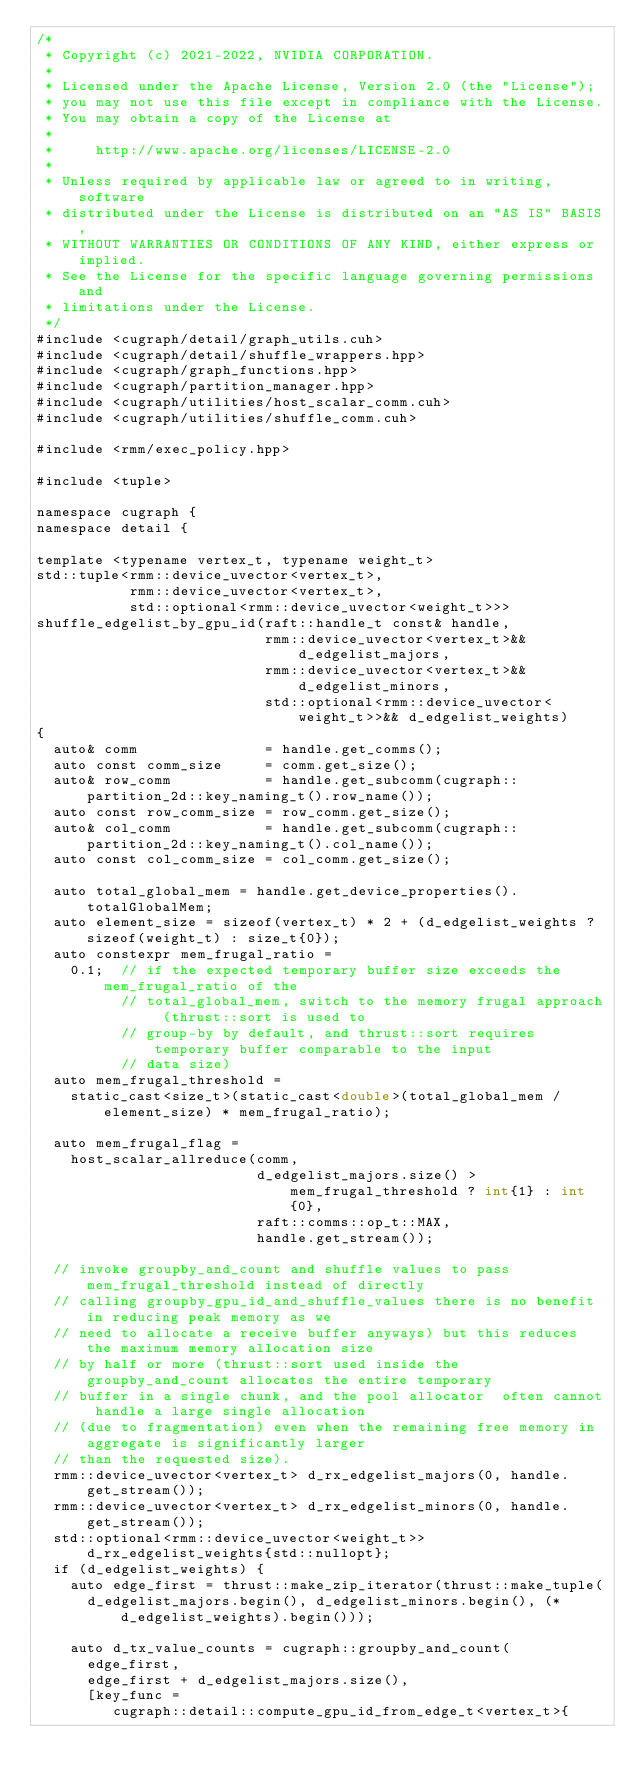<code> <loc_0><loc_0><loc_500><loc_500><_Cuda_>/*
 * Copyright (c) 2021-2022, NVIDIA CORPORATION.
 *
 * Licensed under the Apache License, Version 2.0 (the "License");
 * you may not use this file except in compliance with the License.
 * You may obtain a copy of the License at
 *
 *     http://www.apache.org/licenses/LICENSE-2.0
 *
 * Unless required by applicable law or agreed to in writing, software
 * distributed under the License is distributed on an "AS IS" BASIS,
 * WITHOUT WARRANTIES OR CONDITIONS OF ANY KIND, either express or implied.
 * See the License for the specific language governing permissions and
 * limitations under the License.
 */
#include <cugraph/detail/graph_utils.cuh>
#include <cugraph/detail/shuffle_wrappers.hpp>
#include <cugraph/graph_functions.hpp>
#include <cugraph/partition_manager.hpp>
#include <cugraph/utilities/host_scalar_comm.cuh>
#include <cugraph/utilities/shuffle_comm.cuh>

#include <rmm/exec_policy.hpp>

#include <tuple>

namespace cugraph {
namespace detail {

template <typename vertex_t, typename weight_t>
std::tuple<rmm::device_uvector<vertex_t>,
           rmm::device_uvector<vertex_t>,
           std::optional<rmm::device_uvector<weight_t>>>
shuffle_edgelist_by_gpu_id(raft::handle_t const& handle,
                           rmm::device_uvector<vertex_t>&& d_edgelist_majors,
                           rmm::device_uvector<vertex_t>&& d_edgelist_minors,
                           std::optional<rmm::device_uvector<weight_t>>&& d_edgelist_weights)
{
  auto& comm               = handle.get_comms();
  auto const comm_size     = comm.get_size();
  auto& row_comm           = handle.get_subcomm(cugraph::partition_2d::key_naming_t().row_name());
  auto const row_comm_size = row_comm.get_size();
  auto& col_comm           = handle.get_subcomm(cugraph::partition_2d::key_naming_t().col_name());
  auto const col_comm_size = col_comm.get_size();

  auto total_global_mem = handle.get_device_properties().totalGlobalMem;
  auto element_size = sizeof(vertex_t) * 2 + (d_edgelist_weights ? sizeof(weight_t) : size_t{0});
  auto constexpr mem_frugal_ratio =
    0.1;  // if the expected temporary buffer size exceeds the mem_frugal_ratio of the
          // total_global_mem, switch to the memory frugal approach (thrust::sort is used to
          // group-by by default, and thrust::sort requires temporary buffer comparable to the input
          // data size)
  auto mem_frugal_threshold =
    static_cast<size_t>(static_cast<double>(total_global_mem / element_size) * mem_frugal_ratio);

  auto mem_frugal_flag =
    host_scalar_allreduce(comm,
                          d_edgelist_majors.size() > mem_frugal_threshold ? int{1} : int{0},
                          raft::comms::op_t::MAX,
                          handle.get_stream());

  // invoke groupby_and_count and shuffle values to pass mem_frugal_threshold instead of directly
  // calling groupby_gpu_id_and_shuffle_values there is no benefit in reducing peak memory as we
  // need to allocate a receive buffer anyways) but this reduces the maximum memory allocation size
  // by half or more (thrust::sort used inside the groupby_and_count allocates the entire temporary
  // buffer in a single chunk, and the pool allocator  often cannot handle a large single allocation
  // (due to fragmentation) even when the remaining free memory in aggregate is significantly larger
  // than the requested size).
  rmm::device_uvector<vertex_t> d_rx_edgelist_majors(0, handle.get_stream());
  rmm::device_uvector<vertex_t> d_rx_edgelist_minors(0, handle.get_stream());
  std::optional<rmm::device_uvector<weight_t>> d_rx_edgelist_weights{std::nullopt};
  if (d_edgelist_weights) {
    auto edge_first = thrust::make_zip_iterator(thrust::make_tuple(
      d_edgelist_majors.begin(), d_edgelist_minors.begin(), (*d_edgelist_weights).begin()));

    auto d_tx_value_counts = cugraph::groupby_and_count(
      edge_first,
      edge_first + d_edgelist_majors.size(),
      [key_func =
         cugraph::detail::compute_gpu_id_from_edge_t<vertex_t>{</code> 